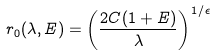Convert formula to latex. <formula><loc_0><loc_0><loc_500><loc_500>r _ { 0 } ( \lambda , E ) = \left ( \frac { 2 C ( 1 + E ) } { \lambda } \right ) ^ { 1 / \epsilon }</formula> 